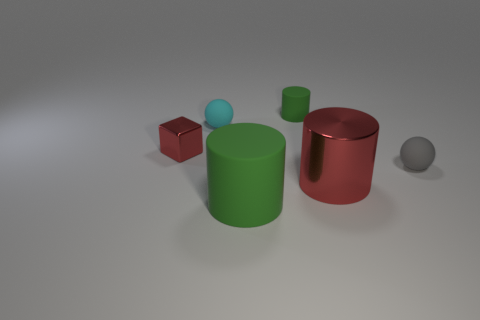Add 1 small rubber objects. How many objects exist? 7 Subtract all blocks. How many objects are left? 5 Subtract all blue spheres. Subtract all small red things. How many objects are left? 5 Add 2 small cyan balls. How many small cyan balls are left? 3 Add 3 small green blocks. How many small green blocks exist? 3 Subtract 0 gray blocks. How many objects are left? 6 